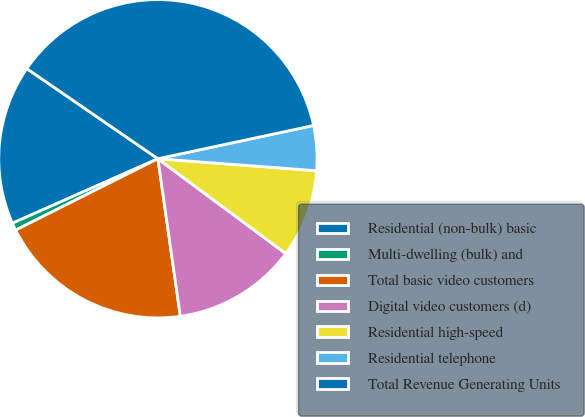Convert chart to OTSL. <chart><loc_0><loc_0><loc_500><loc_500><pie_chart><fcel>Residential (non-bulk) basic<fcel>Multi-dwelling (bulk) and<fcel>Total basic video customers<fcel>Digital video customers (d)<fcel>Residential high-speed<fcel>Residential telephone<fcel>Total Revenue Generating Units<nl><fcel>16.22%<fcel>0.76%<fcel>19.85%<fcel>12.59%<fcel>8.96%<fcel>4.55%<fcel>37.06%<nl></chart> 